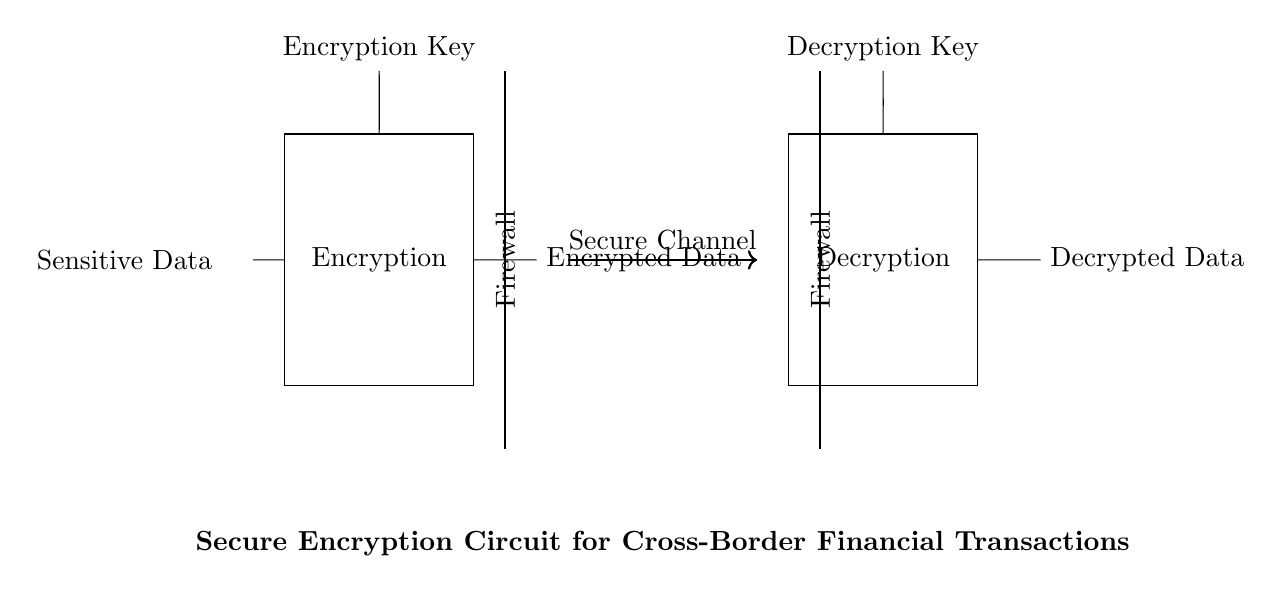What does the rectangle represent in the circuit? The rectangle in the circuit indicates an encryption block, which processes sensitive data to protect it.
Answer: Encryption What are the inputs for the encryption block? The inputs for the encryption block are the sensitive data and the encryption key, which are shown connecting to the block.
Answer: Sensitive Data and Encryption Key How many firewalls are present in this circuit? There are two firewalls in the circuit, one positioned before the decryption block and one before the encryption block.
Answer: Two What type of data does the decryption block output? The decryption block outputs decrypted data, which is the original data after it has been processed by the encryption and secure channel.
Answer: Decrypted Data What is the function of the secure channel in this circuit? The secure channel is the transmission pathway that securely carries encrypted data from the encryption block to the decryption block, protecting it during transfer.
Answer: Transmission What is the relationship between the encryption key and the decryption key? The encryption key encrypts the sensitive data, while the decryption key is necessary to decrypt the data back to its original form after transmission.
Answer: Complementary What is the main purpose of this entire circuit diagram? The main purpose of this circuit diagram is to illustrate the process of securely encrypting sensitive financial data for cross-border transactions to prevent unauthorized access.
Answer: Secure Encryption 